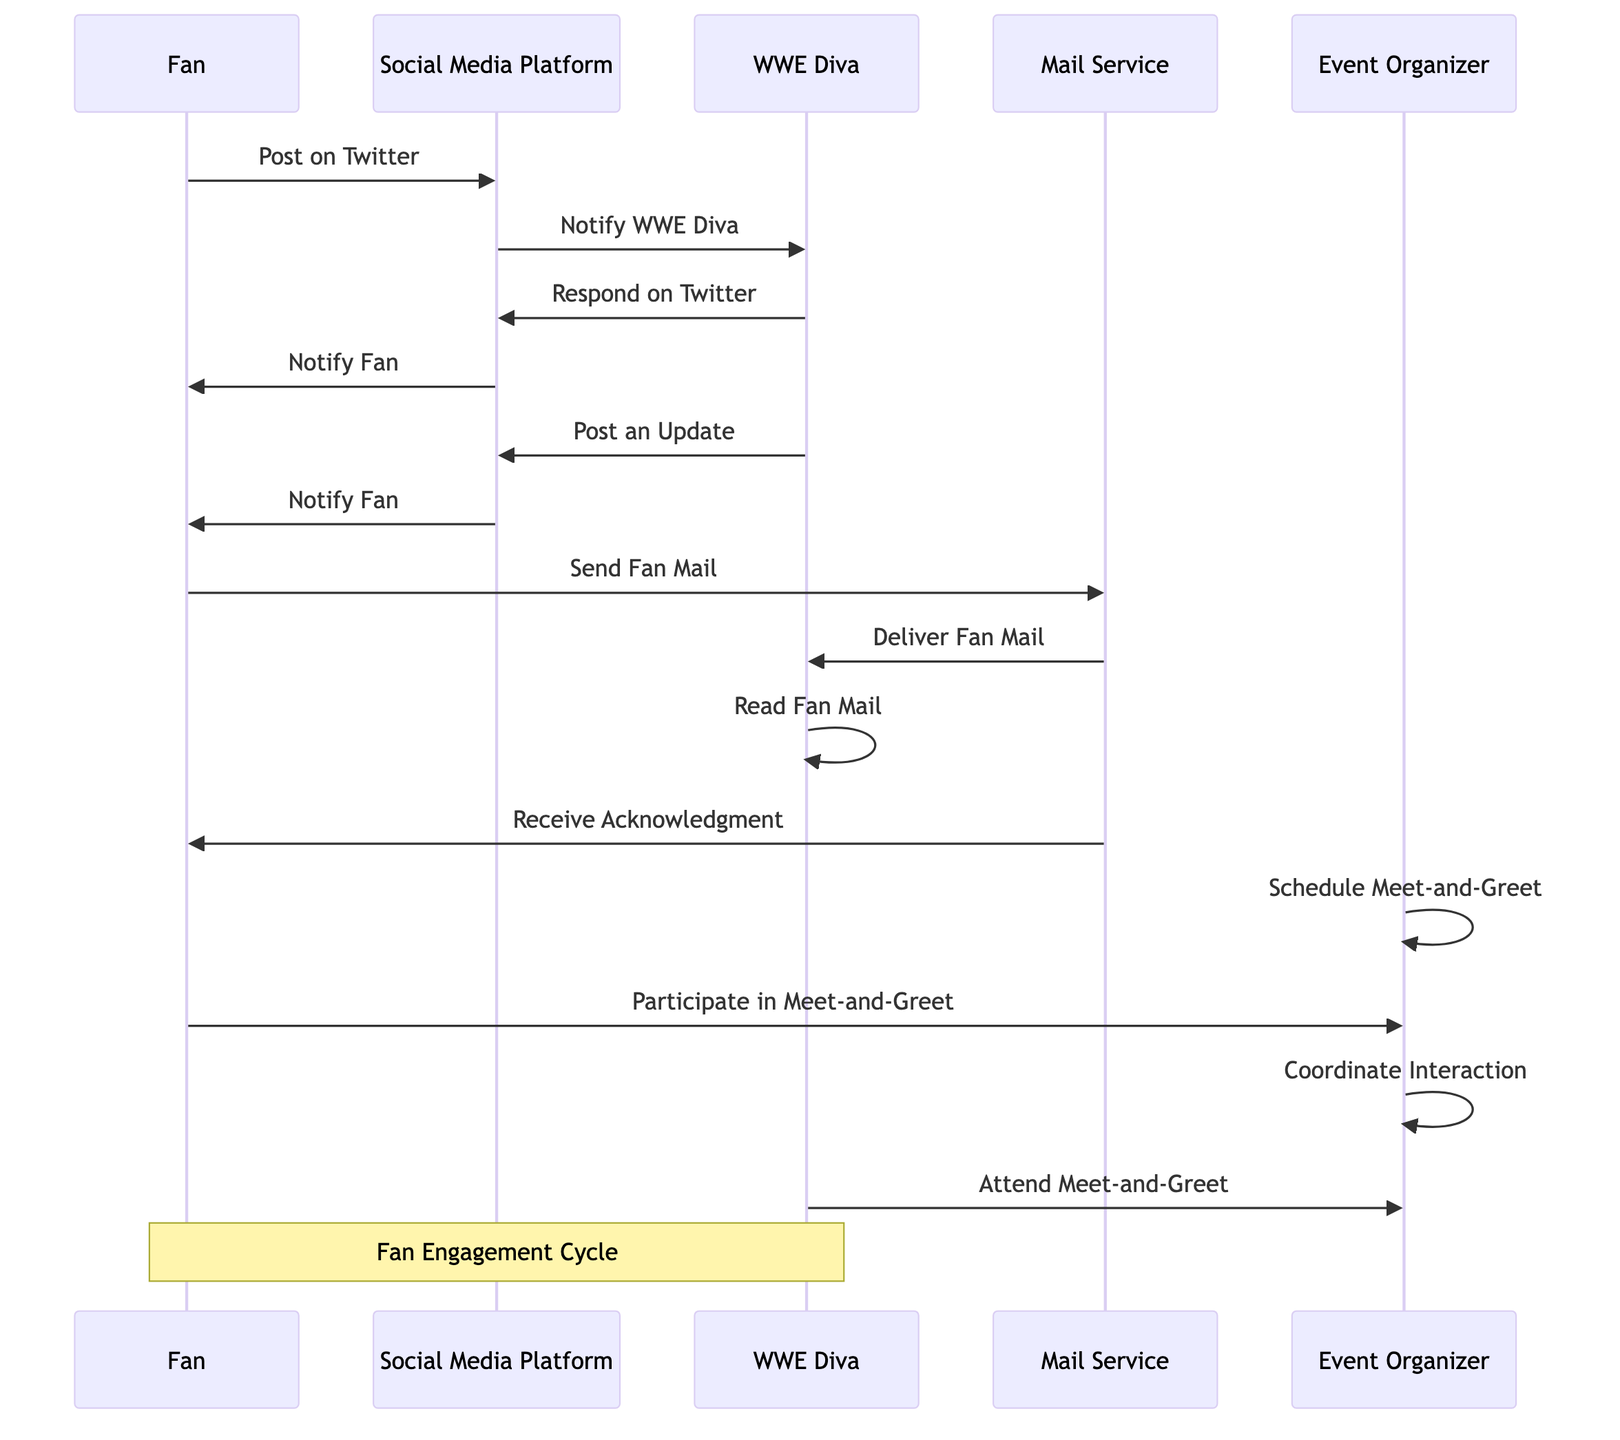What is the first action a fan takes in the diagram? According to the diagram, the first action taken by the fan is to post on Twitter. This can be observed as the fan initiates the interaction leading to subsequent actions.
Answer: Post on Twitter How many actions does the WWE Diva perform in response to the fan's engagement? The WWE Diva performs four actions: responding on Twitter, posting an update, reading fan mail, and attending the meet-and-greet. These actions can be counted directly from the diagram under the WWE Diva's section.
Answer: Four What does the social media platform do after the fan posts on Twitter? After the fan posts on Twitter, the social media platform notifies WWE Diva about the fan's interaction, which is clearly labeled in the diagram.
Answer: Notify WWE Diva What is the last action taken by the organizer in the sequence? The last action taken by the organizer in the diagram is to coordinate interaction, which is reflected toward the end of the sequence after scheduling the meet-and-greet and before the WWE Diva attends it.
Answer: Coordinate Interaction How does the fan know they have received an acknowledgment for their fan mail? The fan is notified when they receive an acknowledgment after the mail service delivers the fan mail and the WWE Diva reads it. This sequence is explicitly shown in the diagram where it connects the mail service actions to the fan's acknowledgment.
Answer: Receive Acknowledgment Which entity manages the logistics for the meet-and-greet? The event organizer manages the logistics for the meet-and-greet, as described in the actions listed under the event organizer entity in the diagram.
Answer: Event Organizer What happens after WWE Diva posts an update on social media? After the WWE Diva posts an update, the social media platform notifies the fan about the new post. The sequence clearly shows this interaction following the diva's action.
Answer: Notify Fan What action occurs immediately after the fan sends fan mail? Immediately after the fan sends fan mail, the mail service delivers the fan mail to the WWE Diva, creating a direct flow of action from one step to the next in the diagram.
Answer: Deliver Fan Mail 